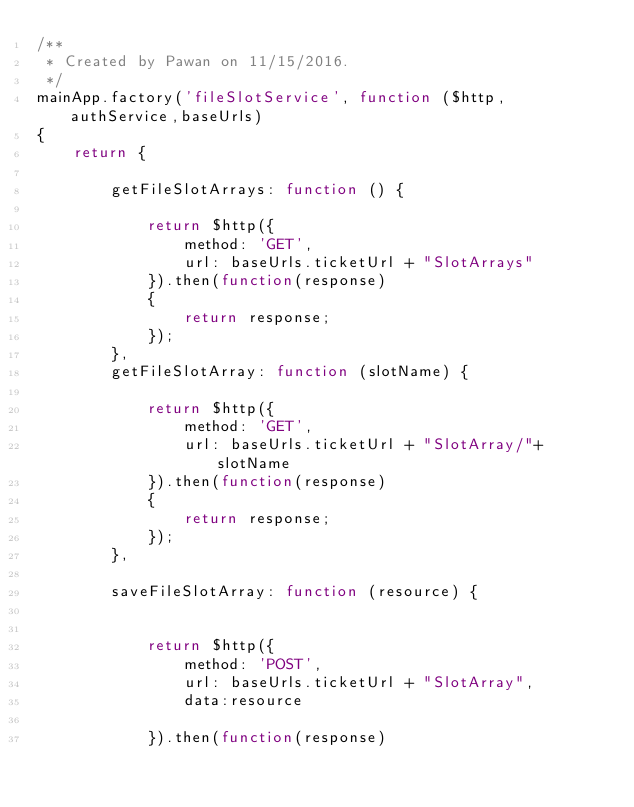Convert code to text. <code><loc_0><loc_0><loc_500><loc_500><_JavaScript_>/**
 * Created by Pawan on 11/15/2016.
 */
mainApp.factory('fileSlotService', function ($http, authService,baseUrls)
{
    return {

        getFileSlotArrays: function () {

            return $http({
                method: 'GET',
                url: baseUrls.ticketUrl + "SlotArrays"
            }).then(function(response)
            {
                return response;
            });
        },
        getFileSlotArray: function (slotName) {

            return $http({
                method: 'GET',
                url: baseUrls.ticketUrl + "SlotArray/"+slotName
            }).then(function(response)
            {
                return response;
            });
        },

        saveFileSlotArray: function (resource) {


            return $http({
                method: 'POST',
                url: baseUrls.ticketUrl + "SlotArray",
                data:resource

            }).then(function(response)</code> 